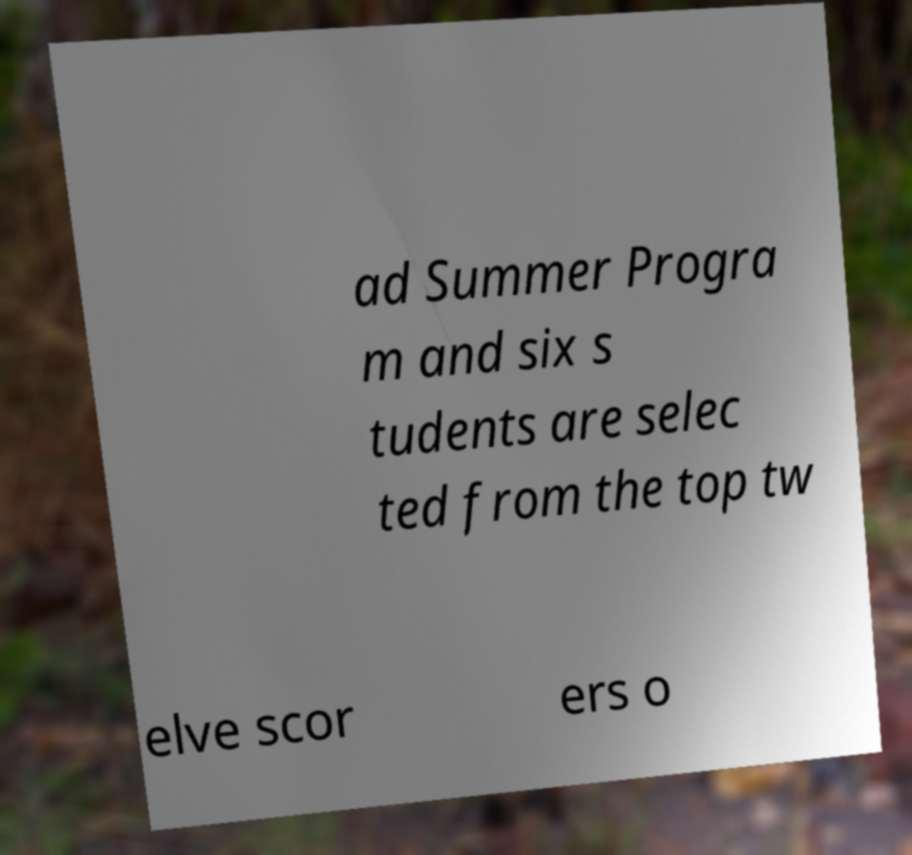Please identify and transcribe the text found in this image. ad Summer Progra m and six s tudents are selec ted from the top tw elve scor ers o 